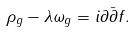Convert formula to latex. <formula><loc_0><loc_0><loc_500><loc_500>\rho _ { g } - \lambda \omega _ { g } = i \partial \bar { \partial } f .</formula> 